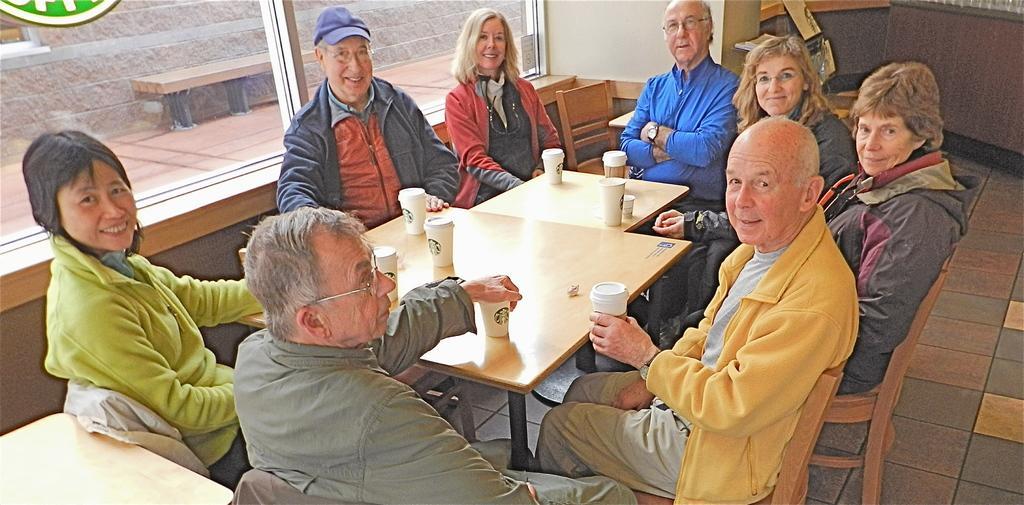In one or two sentences, can you explain what this image depicts? In this picture we can see a group of people sitting on chair and smiling and in front of them there is table and on table we can see glasses and in background we can see bench, window, wall. 